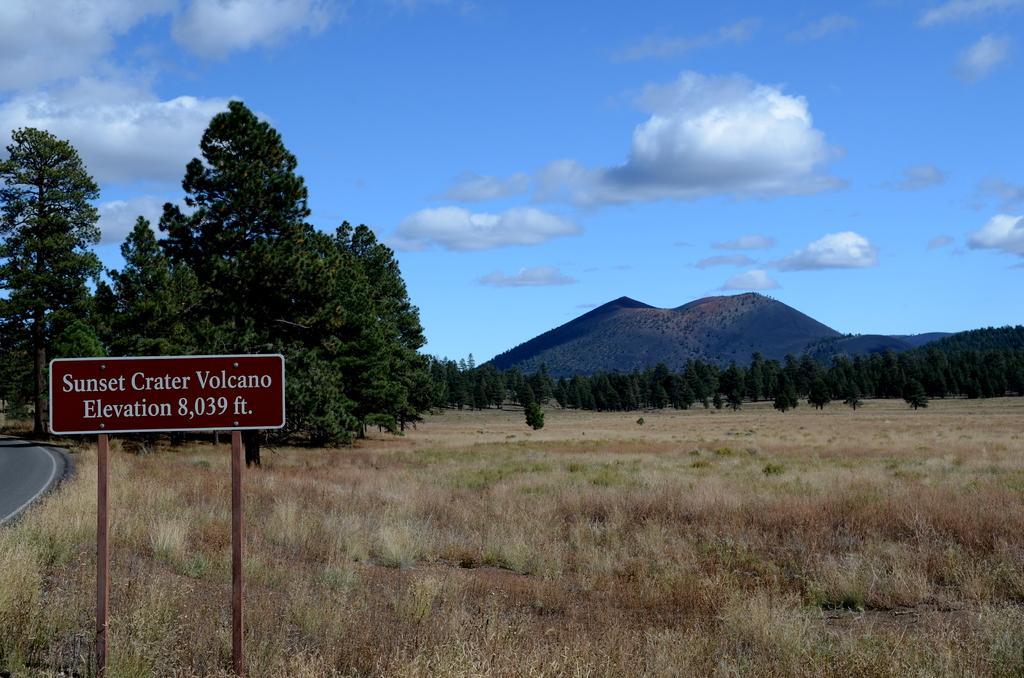In one or two sentences, can you explain what this image depicts? In this image at the bottom there are some plants and sand, and on the left side there is a board. And in the background there are trees, mountains and at the top there is sky. And on the left side of the image there is road. 